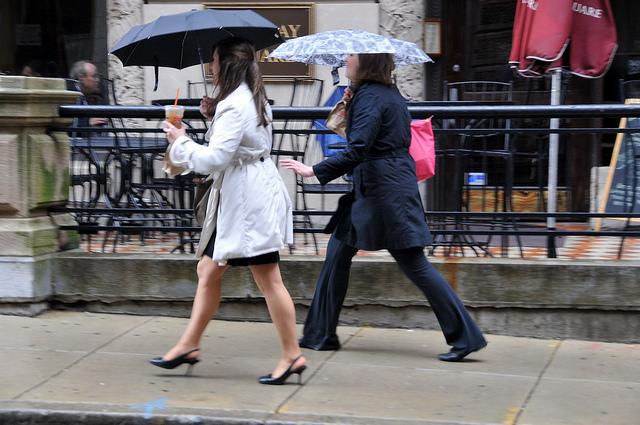Are the umbrellas open?
Be succinct. Yes. Are these two women's umbrellas the same color?
Give a very brief answer. No. What type of shoe is the lady wearing in white?
Be succinct. Heels. 